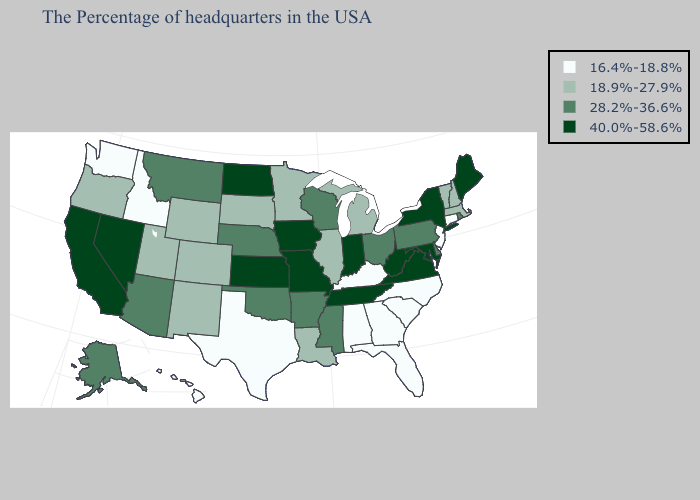What is the value of Iowa?
Keep it brief. 40.0%-58.6%. Does the map have missing data?
Write a very short answer. No. Name the states that have a value in the range 28.2%-36.6%?
Concise answer only. Rhode Island, Delaware, Pennsylvania, Ohio, Wisconsin, Mississippi, Arkansas, Nebraska, Oklahoma, Montana, Arizona, Alaska. Which states hav the highest value in the South?
Keep it brief. Maryland, Virginia, West Virginia, Tennessee. Name the states that have a value in the range 28.2%-36.6%?
Short answer required. Rhode Island, Delaware, Pennsylvania, Ohio, Wisconsin, Mississippi, Arkansas, Nebraska, Oklahoma, Montana, Arizona, Alaska. Name the states that have a value in the range 40.0%-58.6%?
Give a very brief answer. Maine, New York, Maryland, Virginia, West Virginia, Indiana, Tennessee, Missouri, Iowa, Kansas, North Dakota, Nevada, California. How many symbols are there in the legend?
Concise answer only. 4. What is the value of New Mexico?
Give a very brief answer. 18.9%-27.9%. What is the highest value in the Northeast ?
Quick response, please. 40.0%-58.6%. Name the states that have a value in the range 40.0%-58.6%?
Give a very brief answer. Maine, New York, Maryland, Virginia, West Virginia, Indiana, Tennessee, Missouri, Iowa, Kansas, North Dakota, Nevada, California. What is the lowest value in states that border Nevada?
Write a very short answer. 16.4%-18.8%. Does the map have missing data?
Write a very short answer. No. What is the lowest value in states that border Indiana?
Short answer required. 16.4%-18.8%. Which states have the lowest value in the USA?
Write a very short answer. Connecticut, New Jersey, North Carolina, South Carolina, Florida, Georgia, Kentucky, Alabama, Texas, Idaho, Washington, Hawaii. What is the value of Connecticut?
Answer briefly. 16.4%-18.8%. 